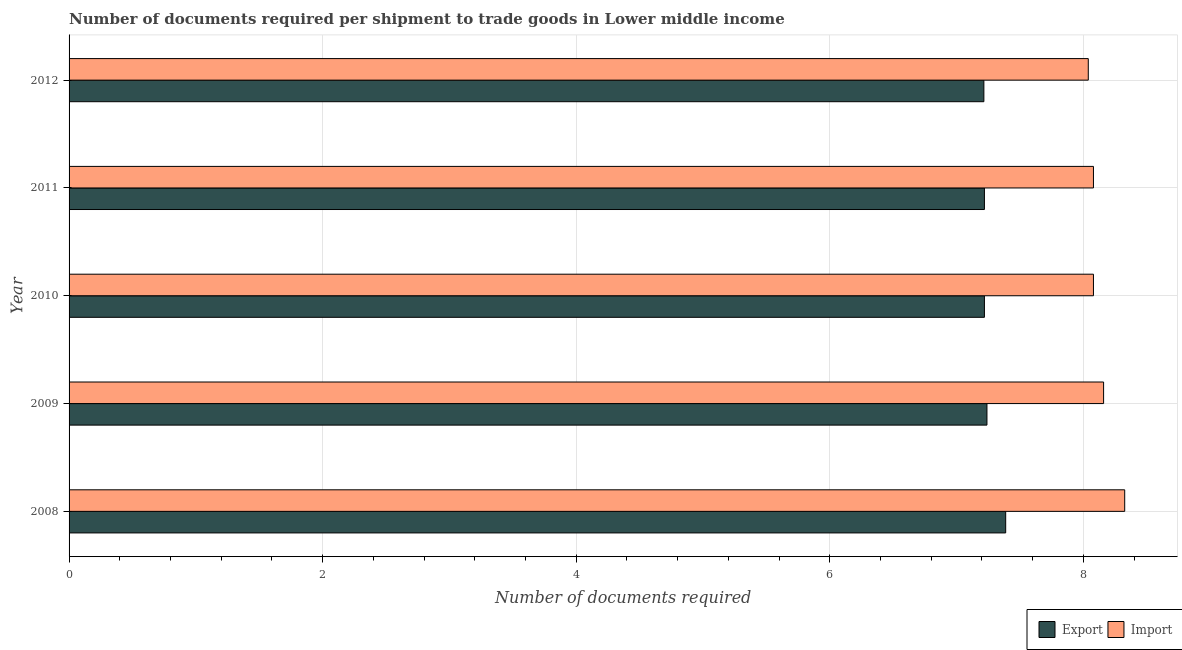How many groups of bars are there?
Provide a succinct answer. 5. Are the number of bars per tick equal to the number of legend labels?
Keep it short and to the point. Yes. How many bars are there on the 4th tick from the bottom?
Offer a terse response. 2. What is the label of the 2nd group of bars from the top?
Your answer should be compact. 2011. In how many cases, is the number of bars for a given year not equal to the number of legend labels?
Provide a short and direct response. 0. What is the number of documents required to export goods in 2009?
Your answer should be compact. 7.24. Across all years, what is the maximum number of documents required to import goods?
Keep it short and to the point. 8.33. Across all years, what is the minimum number of documents required to import goods?
Your answer should be compact. 8.04. In which year was the number of documents required to export goods minimum?
Offer a terse response. 2012. What is the total number of documents required to import goods in the graph?
Offer a terse response. 40.69. What is the difference between the number of documents required to import goods in 2009 and that in 2012?
Make the answer very short. 0.12. What is the difference between the number of documents required to export goods in 2010 and the number of documents required to import goods in 2011?
Your response must be concise. -0.86. What is the average number of documents required to export goods per year?
Provide a short and direct response. 7.26. In the year 2011, what is the difference between the number of documents required to import goods and number of documents required to export goods?
Your answer should be compact. 0.86. In how many years, is the number of documents required to import goods greater than 5.6 ?
Offer a very short reply. 5. What is the ratio of the number of documents required to import goods in 2008 to that in 2011?
Your response must be concise. 1.03. What is the difference between the highest and the second highest number of documents required to import goods?
Provide a short and direct response. 0.17. What is the difference between the highest and the lowest number of documents required to export goods?
Your answer should be compact. 0.17. In how many years, is the number of documents required to export goods greater than the average number of documents required to export goods taken over all years?
Provide a succinct answer. 1. What does the 1st bar from the top in 2011 represents?
Your answer should be compact. Import. What does the 1st bar from the bottom in 2008 represents?
Provide a succinct answer. Export. How many years are there in the graph?
Offer a terse response. 5. Are the values on the major ticks of X-axis written in scientific E-notation?
Offer a very short reply. No. Does the graph contain grids?
Offer a terse response. Yes. How many legend labels are there?
Your response must be concise. 2. How are the legend labels stacked?
Make the answer very short. Horizontal. What is the title of the graph?
Keep it short and to the point. Number of documents required per shipment to trade goods in Lower middle income. What is the label or title of the X-axis?
Your answer should be very brief. Number of documents required. What is the label or title of the Y-axis?
Ensure brevity in your answer.  Year. What is the Number of documents required of Export in 2008?
Provide a succinct answer. 7.39. What is the Number of documents required of Import in 2008?
Provide a succinct answer. 8.33. What is the Number of documents required in Export in 2009?
Your answer should be very brief. 7.24. What is the Number of documents required in Import in 2009?
Your response must be concise. 8.16. What is the Number of documents required of Export in 2010?
Offer a very short reply. 7.22. What is the Number of documents required of Import in 2010?
Ensure brevity in your answer.  8.08. What is the Number of documents required in Export in 2011?
Your answer should be very brief. 7.22. What is the Number of documents required of Import in 2011?
Provide a succinct answer. 8.08. What is the Number of documents required in Export in 2012?
Make the answer very short. 7.22. What is the Number of documents required of Import in 2012?
Provide a short and direct response. 8.04. Across all years, what is the maximum Number of documents required in Export?
Offer a very short reply. 7.39. Across all years, what is the maximum Number of documents required in Import?
Make the answer very short. 8.33. Across all years, what is the minimum Number of documents required of Export?
Provide a succinct answer. 7.22. Across all years, what is the minimum Number of documents required in Import?
Ensure brevity in your answer.  8.04. What is the total Number of documents required of Export in the graph?
Your answer should be compact. 36.28. What is the total Number of documents required of Import in the graph?
Give a very brief answer. 40.69. What is the difference between the Number of documents required in Export in 2008 and that in 2009?
Offer a terse response. 0.15. What is the difference between the Number of documents required of Import in 2008 and that in 2009?
Ensure brevity in your answer.  0.17. What is the difference between the Number of documents required in Export in 2008 and that in 2010?
Your answer should be very brief. 0.17. What is the difference between the Number of documents required of Import in 2008 and that in 2010?
Give a very brief answer. 0.25. What is the difference between the Number of documents required of Export in 2008 and that in 2011?
Your answer should be compact. 0.17. What is the difference between the Number of documents required in Import in 2008 and that in 2011?
Provide a succinct answer. 0.25. What is the difference between the Number of documents required in Export in 2008 and that in 2012?
Offer a very short reply. 0.17. What is the difference between the Number of documents required of Import in 2008 and that in 2012?
Keep it short and to the point. 0.29. What is the difference between the Number of documents required in Export in 2009 and that in 2012?
Provide a succinct answer. 0.02. What is the difference between the Number of documents required in Import in 2009 and that in 2012?
Make the answer very short. 0.12. What is the difference between the Number of documents required of Export in 2010 and that in 2012?
Offer a very short reply. 0. What is the difference between the Number of documents required of Import in 2010 and that in 2012?
Your answer should be compact. 0.04. What is the difference between the Number of documents required in Export in 2011 and that in 2012?
Offer a terse response. 0. What is the difference between the Number of documents required of Import in 2011 and that in 2012?
Make the answer very short. 0.04. What is the difference between the Number of documents required in Export in 2008 and the Number of documents required in Import in 2009?
Keep it short and to the point. -0.77. What is the difference between the Number of documents required of Export in 2008 and the Number of documents required of Import in 2010?
Offer a very short reply. -0.69. What is the difference between the Number of documents required of Export in 2008 and the Number of documents required of Import in 2011?
Offer a very short reply. -0.69. What is the difference between the Number of documents required in Export in 2008 and the Number of documents required in Import in 2012?
Keep it short and to the point. -0.65. What is the difference between the Number of documents required of Export in 2009 and the Number of documents required of Import in 2010?
Your response must be concise. -0.84. What is the difference between the Number of documents required in Export in 2009 and the Number of documents required in Import in 2011?
Make the answer very short. -0.84. What is the difference between the Number of documents required in Export in 2009 and the Number of documents required in Import in 2012?
Give a very brief answer. -0.8. What is the difference between the Number of documents required of Export in 2010 and the Number of documents required of Import in 2011?
Your response must be concise. -0.86. What is the difference between the Number of documents required of Export in 2010 and the Number of documents required of Import in 2012?
Your answer should be compact. -0.82. What is the difference between the Number of documents required in Export in 2011 and the Number of documents required in Import in 2012?
Provide a succinct answer. -0.82. What is the average Number of documents required of Export per year?
Your response must be concise. 7.26. What is the average Number of documents required of Import per year?
Give a very brief answer. 8.14. In the year 2008, what is the difference between the Number of documents required in Export and Number of documents required in Import?
Offer a very short reply. -0.94. In the year 2009, what is the difference between the Number of documents required in Export and Number of documents required in Import?
Give a very brief answer. -0.92. In the year 2010, what is the difference between the Number of documents required of Export and Number of documents required of Import?
Provide a succinct answer. -0.86. In the year 2011, what is the difference between the Number of documents required in Export and Number of documents required in Import?
Your response must be concise. -0.86. In the year 2012, what is the difference between the Number of documents required in Export and Number of documents required in Import?
Keep it short and to the point. -0.82. What is the ratio of the Number of documents required of Export in 2008 to that in 2009?
Your response must be concise. 1.02. What is the ratio of the Number of documents required in Import in 2008 to that in 2009?
Your answer should be very brief. 1.02. What is the ratio of the Number of documents required in Export in 2008 to that in 2010?
Make the answer very short. 1.02. What is the ratio of the Number of documents required in Import in 2008 to that in 2010?
Your answer should be compact. 1.03. What is the ratio of the Number of documents required of Export in 2008 to that in 2011?
Keep it short and to the point. 1.02. What is the ratio of the Number of documents required in Import in 2008 to that in 2011?
Offer a very short reply. 1.03. What is the ratio of the Number of documents required of Export in 2008 to that in 2012?
Provide a short and direct response. 1.02. What is the ratio of the Number of documents required of Import in 2008 to that in 2012?
Ensure brevity in your answer.  1.04. What is the ratio of the Number of documents required of Import in 2009 to that in 2010?
Offer a terse response. 1.01. What is the ratio of the Number of documents required of Export in 2009 to that in 2011?
Your answer should be compact. 1. What is the ratio of the Number of documents required in Import in 2009 to that in 2011?
Your answer should be very brief. 1.01. What is the ratio of the Number of documents required of Export in 2009 to that in 2012?
Provide a short and direct response. 1. What is the ratio of the Number of documents required of Import in 2009 to that in 2012?
Provide a short and direct response. 1.01. What is the ratio of the Number of documents required in Export in 2010 to that in 2012?
Give a very brief answer. 1. What is the ratio of the Number of documents required in Import in 2010 to that in 2012?
Ensure brevity in your answer.  1.01. What is the difference between the highest and the second highest Number of documents required of Export?
Your answer should be compact. 0.15. What is the difference between the highest and the second highest Number of documents required in Import?
Ensure brevity in your answer.  0.17. What is the difference between the highest and the lowest Number of documents required of Export?
Provide a succinct answer. 0.17. What is the difference between the highest and the lowest Number of documents required in Import?
Your response must be concise. 0.29. 